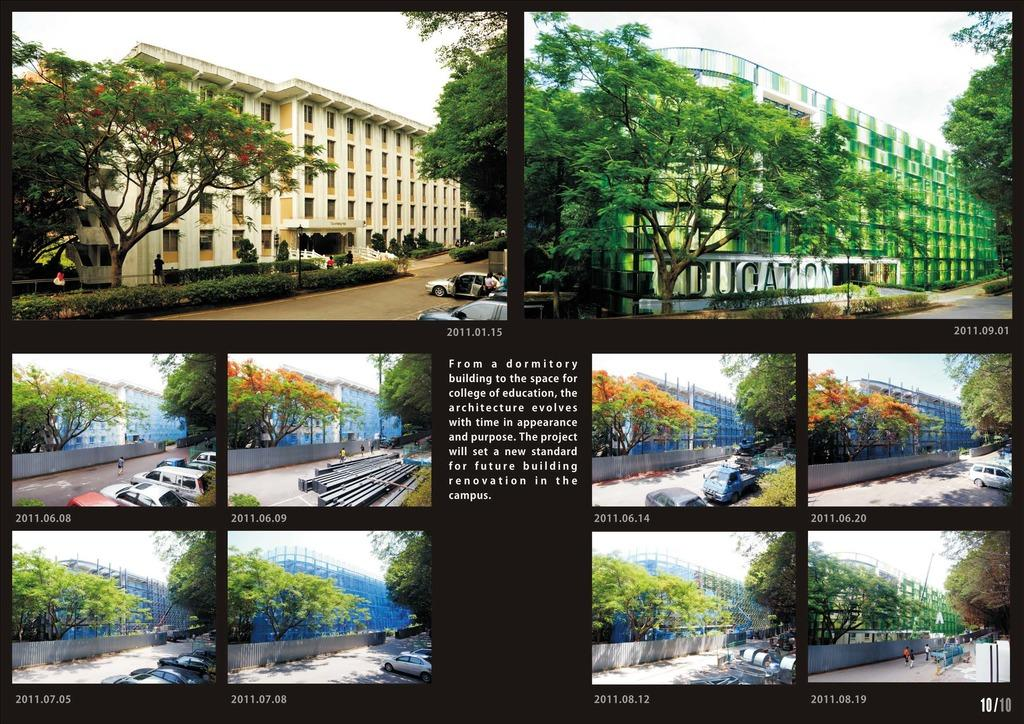What type of structures can be seen in the image? There are buildings in the image. What other elements are present in the image besides buildings? There are trees, vehicles, people, and text in the image. How much dust can be seen on the range in the image? There is no range or dust present in the image. 